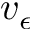Convert formula to latex. <formula><loc_0><loc_0><loc_500><loc_500>v _ { \epsilon }</formula> 